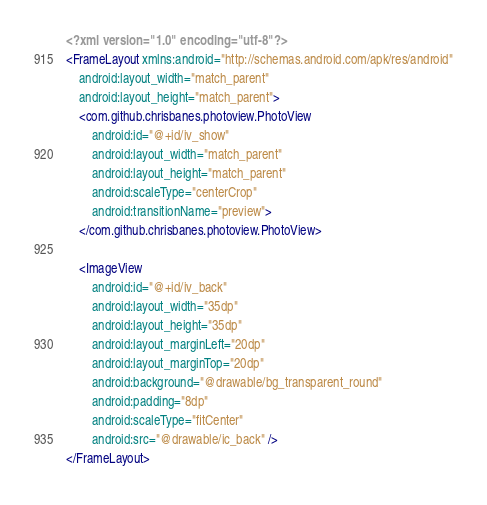Convert code to text. <code><loc_0><loc_0><loc_500><loc_500><_XML_><?xml version="1.0" encoding="utf-8"?>
<FrameLayout xmlns:android="http://schemas.android.com/apk/res/android"
    android:layout_width="match_parent"
    android:layout_height="match_parent">
    <com.github.chrisbanes.photoview.PhotoView
        android:id="@+id/iv_show"
        android:layout_width="match_parent"
        android:layout_height="match_parent"
        android:scaleType="centerCrop"
        android:transitionName="preview">
    </com.github.chrisbanes.photoview.PhotoView>

    <ImageView
        android:id="@+id/iv_back"
        android:layout_width="35dp"
        android:layout_height="35dp"
        android:layout_marginLeft="20dp"
        android:layout_marginTop="20dp"
        android:background="@drawable/bg_transparent_round"
        android:padding="8dp"
        android:scaleType="fitCenter"
        android:src="@drawable/ic_back" />
</FrameLayout></code> 